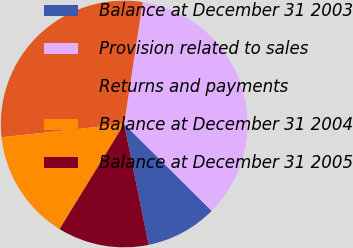Convert chart. <chart><loc_0><loc_0><loc_500><loc_500><pie_chart><fcel>Balance at December 31 2003<fcel>Provision related to sales<fcel>Returns and payments<fcel>Balance at December 31 2004<fcel>Balance at December 31 2005<nl><fcel>9.38%<fcel>35.03%<fcel>29.13%<fcel>14.51%<fcel>11.95%<nl></chart> 